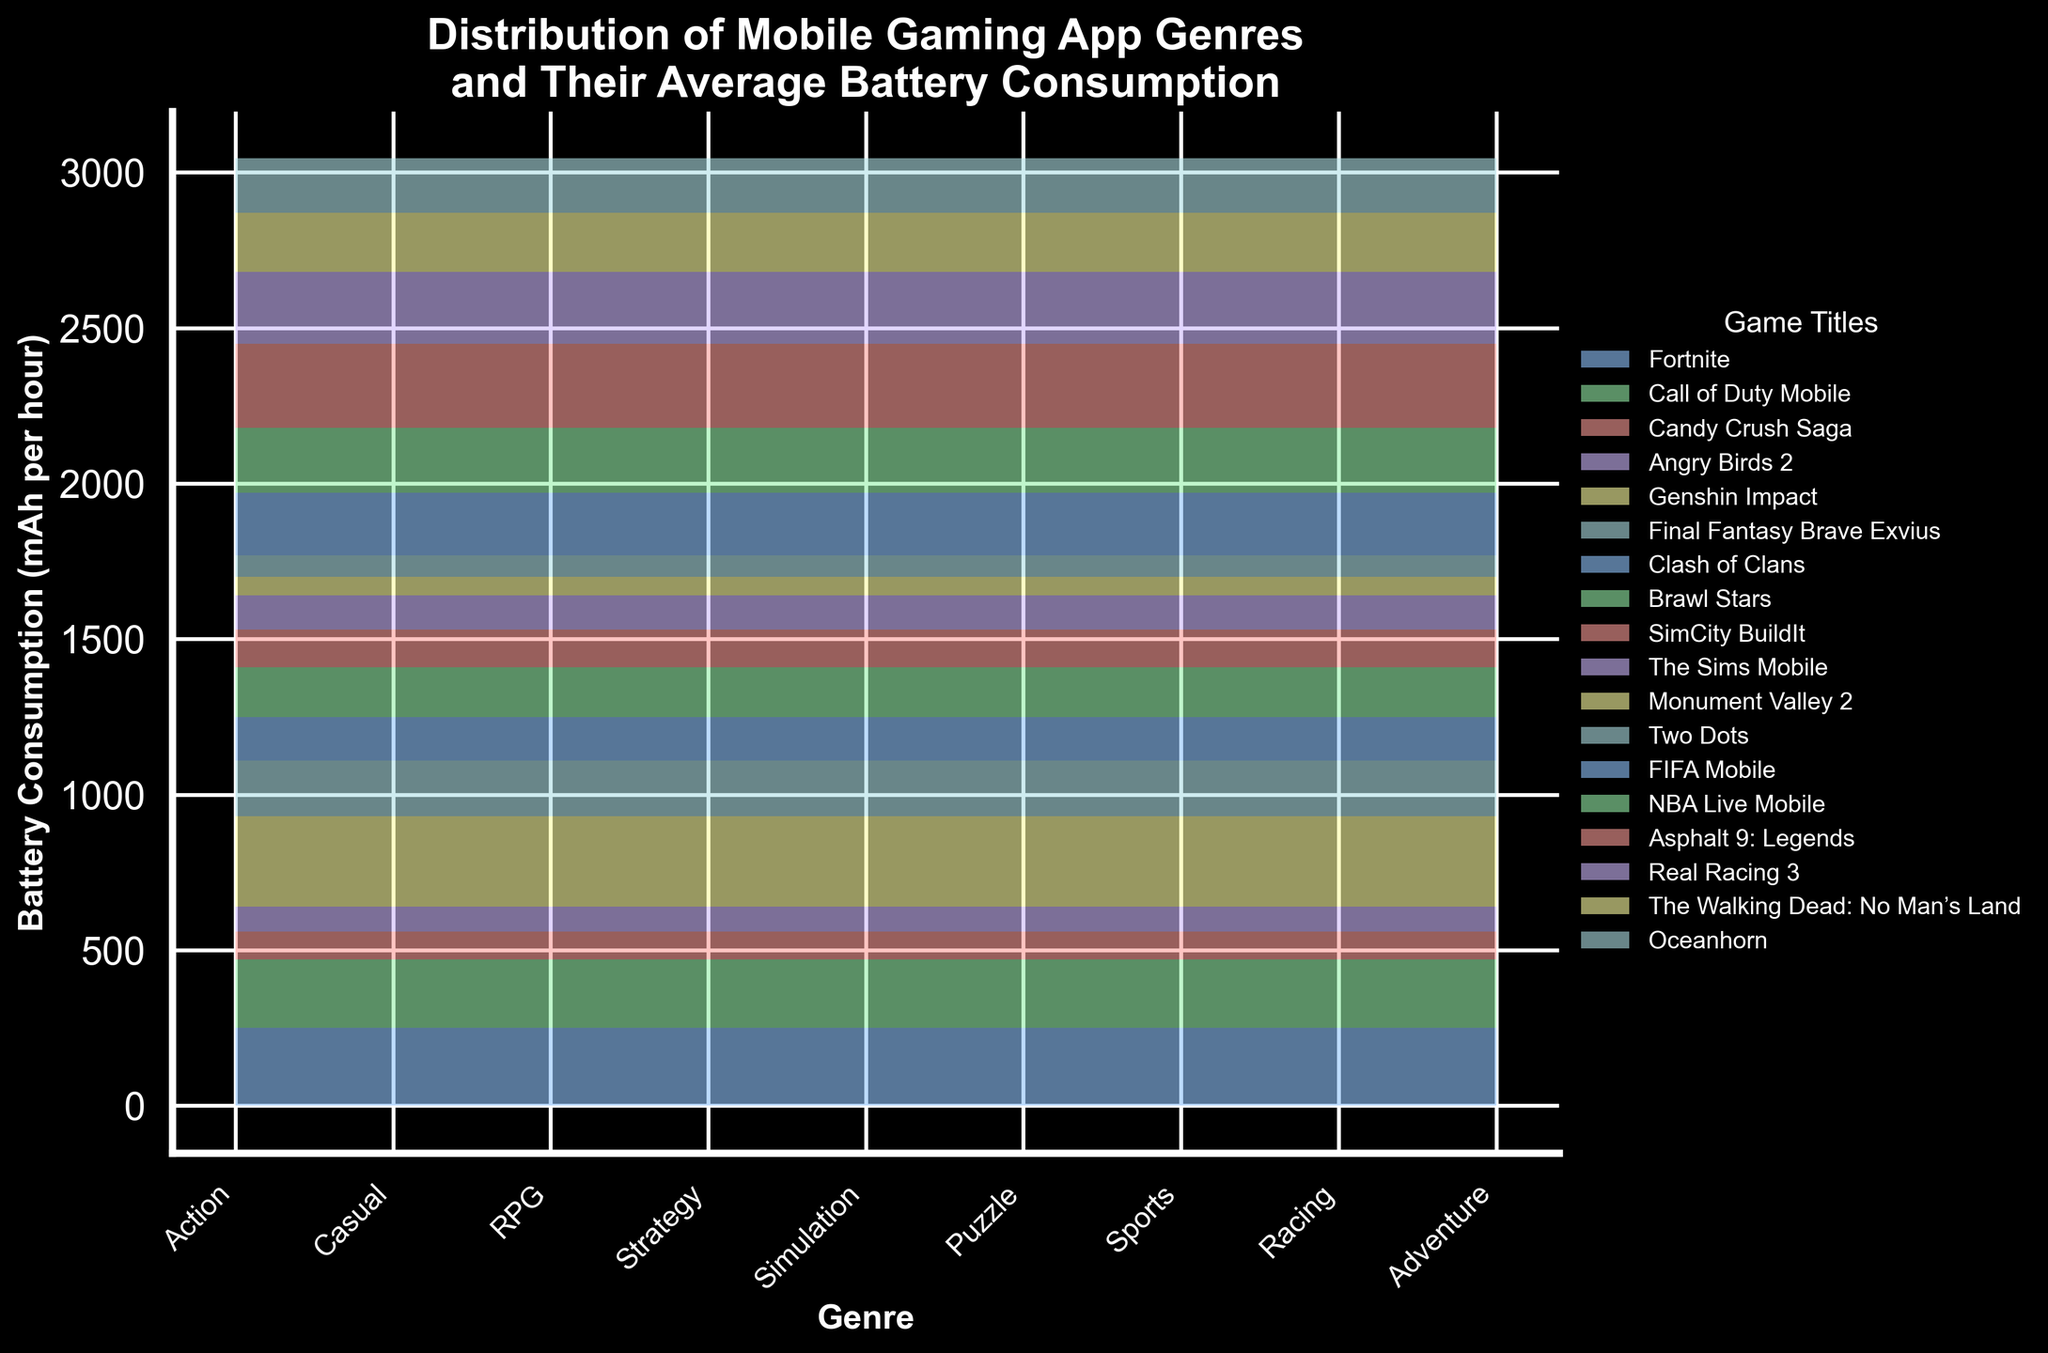What's the title of the figure? Look at the top of the chart where the title is displayed in bold.
Answer: Distribution of Mobile Gaming App Genres and Their Average Battery Consumption How many genres of games are represented in the figure? Count the unique labels on the x-axis of the area chart.
Answer: 7 Which game has the highest battery consumption and what is the value? Find the highest area within any segment in the chart. Look for the game title associated with that large area.
Answer: Genshin Impact, 290 mAh per hour What is the total battery consumption for Casual games? Add the battery consumption values of Candy Crush Saga and Angry Birds 2 under the Casual genre.
Answer: 170 mAh per hour Which genre has the least average battery consumption per game? Calculate the average battery consumption for each genre and compare them.
Answer: Puzzle Compare the battery consumption between Racing and Simulation games. Which one consumes more on average? Calculate the average consumption for each genre by summing their respective values and dividing by the number of games, then compare these averages. Racing: (270 + 230) / 2 = 250, Simulation: (120 + 110) / 2 = 115.
Answer: Racing Which genre has the most varied battery consumption among its games? Look for the genre with the largest difference between the highest and lowest values. RPG: 290 (Genshin Impact) - 180 (Final Fantasy Brave Exvius) = 110 mAh
Answer: RPG What is the battery consumption for the game Call of Duty Mobile? Find the area segment corresponding to Call of Duty Mobile in the Action genre.
Answer: 220 mAh per hour How does the battery consumption of Sports games compare with Adventure games? Compare the sum of battery consumption for Sports (FIFA Mobile, NBA Live Mobile) and Adventure (The Walking Dead, Oceanhorn). Sports: 200 + 210 = 410, Adventure: 190 + 175 = 365.
Answer: Sports consumes more What's the average battery consumption for Action games? Sum the battery consumption for Action games and divide by the number of Action games. Action: (250 + 220) / 2 = 235.
Answer: 235 mAh per hour 